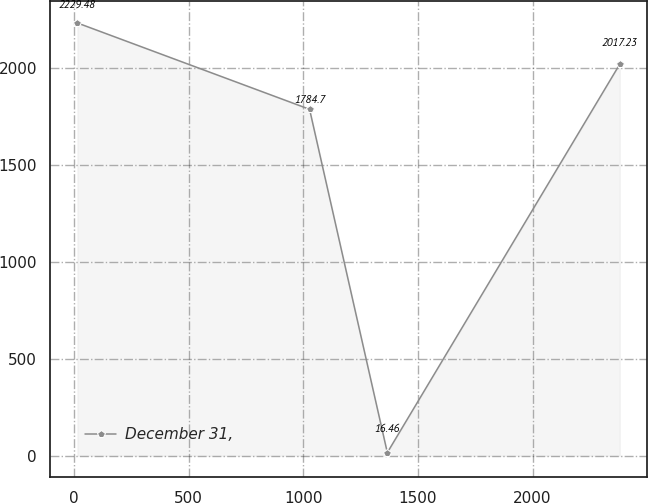<chart> <loc_0><loc_0><loc_500><loc_500><line_chart><ecel><fcel>December 31,<nl><fcel>14.27<fcel>2229.48<nl><fcel>1027.21<fcel>1784.7<nl><fcel>1366.41<fcel>16.46<nl><fcel>2380.5<fcel>2017.23<nl></chart> 